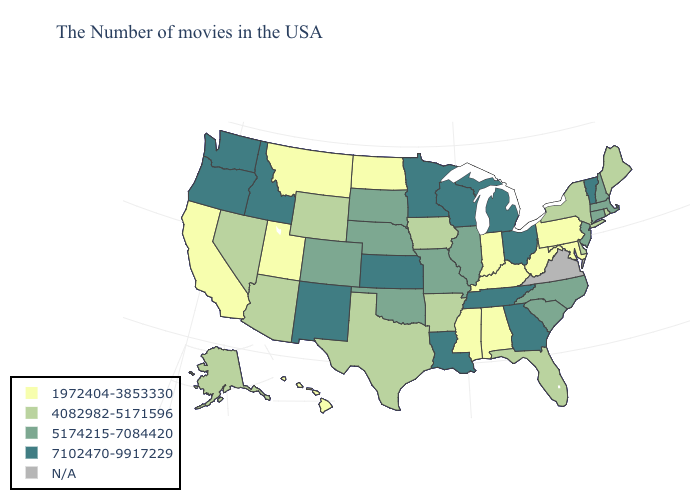What is the value of New York?
Give a very brief answer. 4082982-5171596. Name the states that have a value in the range 5174215-7084420?
Concise answer only. Massachusetts, New Hampshire, Connecticut, New Jersey, North Carolina, South Carolina, Illinois, Missouri, Nebraska, Oklahoma, South Dakota, Colorado. Which states have the highest value in the USA?
Quick response, please. Vermont, Ohio, Georgia, Michigan, Tennessee, Wisconsin, Louisiana, Minnesota, Kansas, New Mexico, Idaho, Washington, Oregon. Which states have the lowest value in the USA?
Quick response, please. Maryland, Pennsylvania, West Virginia, Kentucky, Indiana, Alabama, Mississippi, North Dakota, Utah, Montana, California, Hawaii. What is the value of Missouri?
Concise answer only. 5174215-7084420. Name the states that have a value in the range N/A?
Give a very brief answer. Virginia. Does Massachusetts have the lowest value in the Northeast?
Concise answer only. No. Does Ohio have the highest value in the USA?
Answer briefly. Yes. Among the states that border Montana , does South Dakota have the highest value?
Concise answer only. No. What is the value of Florida?
Quick response, please. 4082982-5171596. Which states have the highest value in the USA?
Quick response, please. Vermont, Ohio, Georgia, Michigan, Tennessee, Wisconsin, Louisiana, Minnesota, Kansas, New Mexico, Idaho, Washington, Oregon. Does Kansas have the highest value in the USA?
Short answer required. Yes. 